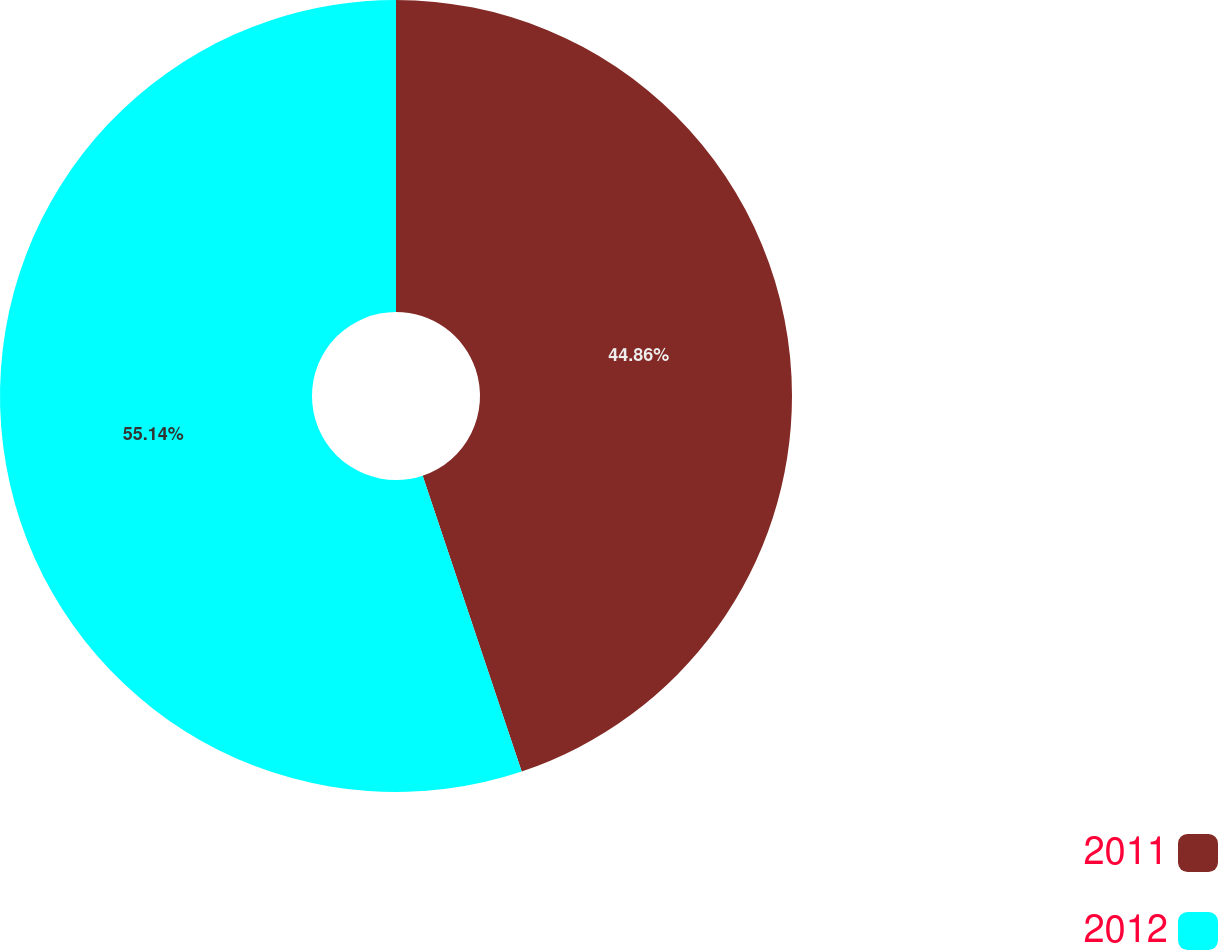Convert chart. <chart><loc_0><loc_0><loc_500><loc_500><pie_chart><fcel>2011<fcel>2012<nl><fcel>44.86%<fcel>55.14%<nl></chart> 